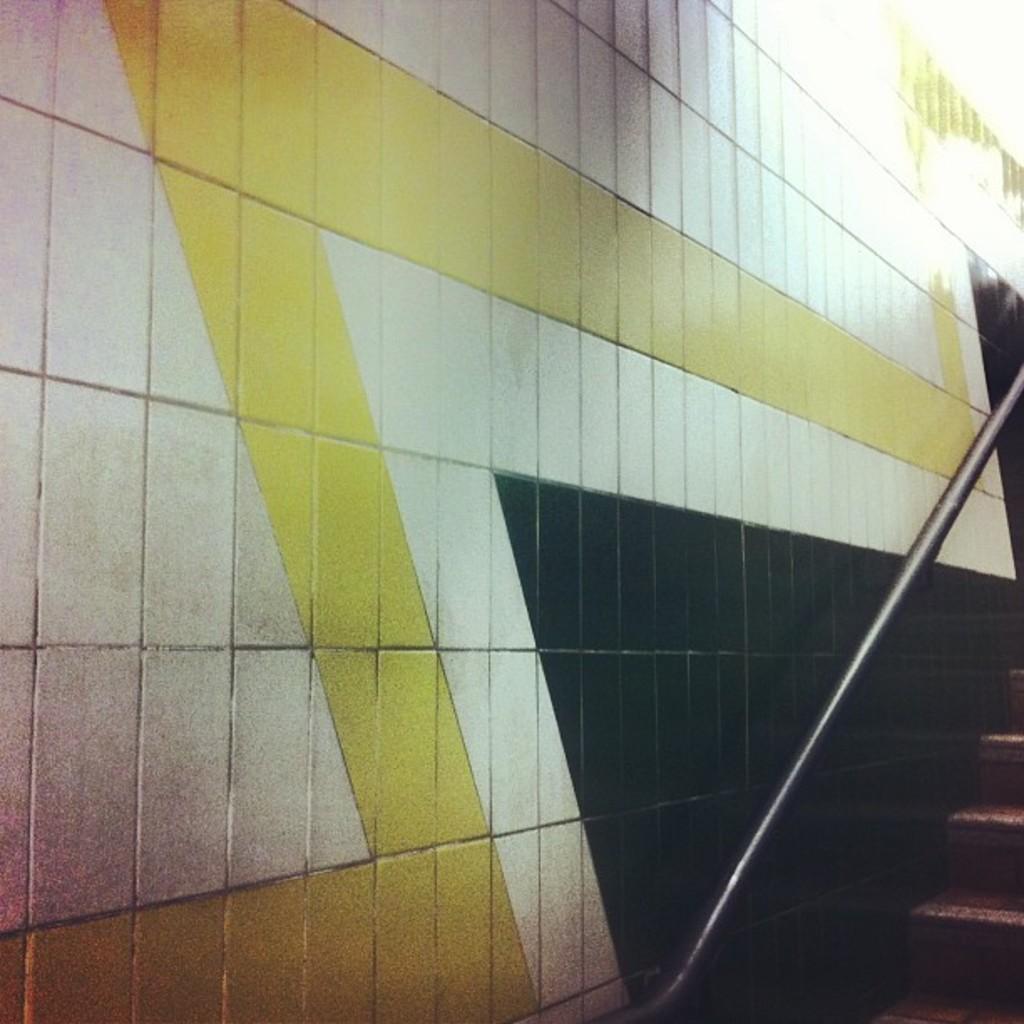Can you describe this image briefly? In the foreground of this image, on the bottom, there are stairs, a railing pole and the wall. 